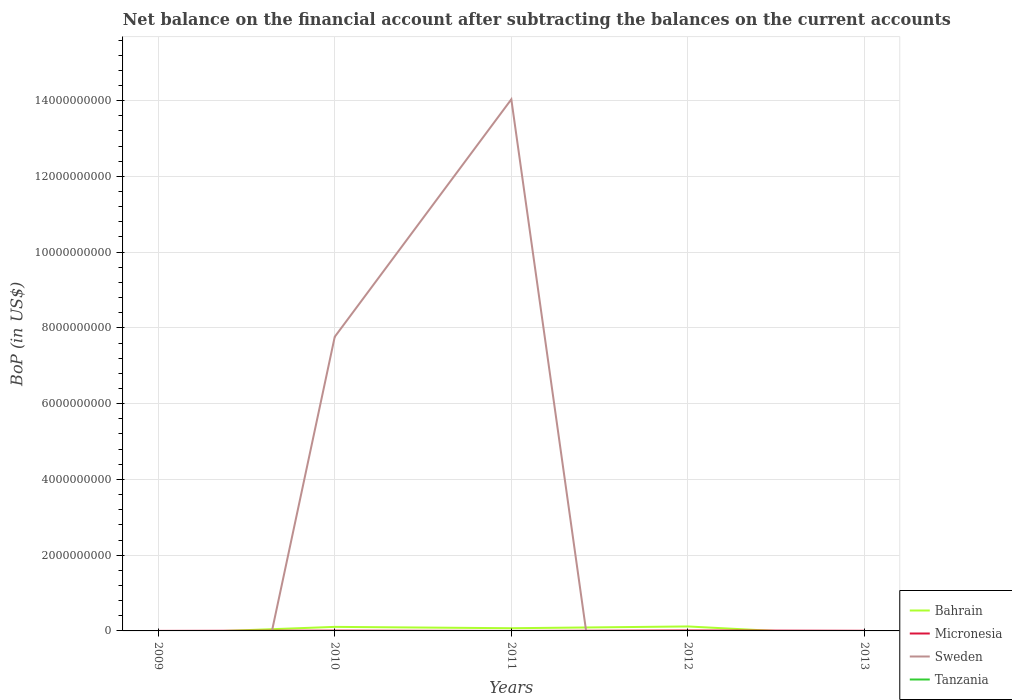How many different coloured lines are there?
Provide a short and direct response. 3. Is the number of lines equal to the number of legend labels?
Keep it short and to the point. No. Across all years, what is the maximum Balance of Payments in Sweden?
Provide a succinct answer. 0. What is the total Balance of Payments in Bahrain in the graph?
Offer a very short reply. 3.54e+07. What is the difference between the highest and the second highest Balance of Payments in Micronesia?
Provide a short and direct response. 1.18e+07. What is the difference between two consecutive major ticks on the Y-axis?
Offer a very short reply. 2.00e+09. Does the graph contain any zero values?
Your answer should be very brief. Yes. Does the graph contain grids?
Your answer should be compact. Yes. How are the legend labels stacked?
Your answer should be compact. Vertical. What is the title of the graph?
Make the answer very short. Net balance on the financial account after subtracting the balances on the current accounts. What is the label or title of the Y-axis?
Provide a succinct answer. BoP (in US$). What is the BoP (in US$) of Micronesia in 2009?
Keep it short and to the point. 9.18e+05. What is the BoP (in US$) of Sweden in 2009?
Keep it short and to the point. 0. What is the BoP (in US$) of Tanzania in 2009?
Give a very brief answer. 0. What is the BoP (in US$) in Bahrain in 2010?
Your answer should be compact. 1.07e+08. What is the BoP (in US$) of Micronesia in 2010?
Provide a short and direct response. 8.05e+06. What is the BoP (in US$) of Sweden in 2010?
Offer a very short reply. 7.76e+09. What is the BoP (in US$) in Tanzania in 2010?
Ensure brevity in your answer.  0. What is the BoP (in US$) in Bahrain in 2011?
Ensure brevity in your answer.  7.15e+07. What is the BoP (in US$) of Sweden in 2011?
Keep it short and to the point. 1.40e+1. What is the BoP (in US$) of Bahrain in 2012?
Your response must be concise. 1.18e+08. What is the BoP (in US$) of Micronesia in 2012?
Offer a terse response. 1.18e+07. What is the BoP (in US$) in Micronesia in 2013?
Ensure brevity in your answer.  3.55e+06. What is the BoP (in US$) of Sweden in 2013?
Make the answer very short. 0. Across all years, what is the maximum BoP (in US$) in Bahrain?
Give a very brief answer. 1.18e+08. Across all years, what is the maximum BoP (in US$) of Micronesia?
Give a very brief answer. 1.18e+07. Across all years, what is the maximum BoP (in US$) of Sweden?
Make the answer very short. 1.40e+1. Across all years, what is the minimum BoP (in US$) in Bahrain?
Provide a succinct answer. 0. Across all years, what is the minimum BoP (in US$) in Micronesia?
Your answer should be very brief. 0. Across all years, what is the minimum BoP (in US$) of Sweden?
Your answer should be very brief. 0. What is the total BoP (in US$) of Bahrain in the graph?
Provide a succinct answer. 2.97e+08. What is the total BoP (in US$) in Micronesia in the graph?
Make the answer very short. 2.43e+07. What is the total BoP (in US$) in Sweden in the graph?
Your response must be concise. 2.18e+1. What is the difference between the BoP (in US$) of Micronesia in 2009 and that in 2010?
Offer a very short reply. -7.13e+06. What is the difference between the BoP (in US$) in Micronesia in 2009 and that in 2012?
Your response must be concise. -1.09e+07. What is the difference between the BoP (in US$) in Micronesia in 2009 and that in 2013?
Your response must be concise. -2.63e+06. What is the difference between the BoP (in US$) in Bahrain in 2010 and that in 2011?
Provide a succinct answer. 3.54e+07. What is the difference between the BoP (in US$) of Sweden in 2010 and that in 2011?
Your response must be concise. -6.27e+09. What is the difference between the BoP (in US$) of Bahrain in 2010 and that in 2012?
Your answer should be compact. -1.11e+07. What is the difference between the BoP (in US$) in Micronesia in 2010 and that in 2012?
Provide a short and direct response. -3.73e+06. What is the difference between the BoP (in US$) in Micronesia in 2010 and that in 2013?
Keep it short and to the point. 4.50e+06. What is the difference between the BoP (in US$) of Bahrain in 2011 and that in 2012?
Provide a succinct answer. -4.65e+07. What is the difference between the BoP (in US$) of Micronesia in 2012 and that in 2013?
Your response must be concise. 8.23e+06. What is the difference between the BoP (in US$) in Micronesia in 2009 and the BoP (in US$) in Sweden in 2010?
Give a very brief answer. -7.76e+09. What is the difference between the BoP (in US$) of Micronesia in 2009 and the BoP (in US$) of Sweden in 2011?
Provide a succinct answer. -1.40e+1. What is the difference between the BoP (in US$) of Bahrain in 2010 and the BoP (in US$) of Sweden in 2011?
Your response must be concise. -1.39e+1. What is the difference between the BoP (in US$) of Micronesia in 2010 and the BoP (in US$) of Sweden in 2011?
Ensure brevity in your answer.  -1.40e+1. What is the difference between the BoP (in US$) in Bahrain in 2010 and the BoP (in US$) in Micronesia in 2012?
Offer a terse response. 9.52e+07. What is the difference between the BoP (in US$) in Bahrain in 2010 and the BoP (in US$) in Micronesia in 2013?
Provide a succinct answer. 1.03e+08. What is the difference between the BoP (in US$) of Bahrain in 2011 and the BoP (in US$) of Micronesia in 2012?
Provide a short and direct response. 5.98e+07. What is the difference between the BoP (in US$) of Bahrain in 2011 and the BoP (in US$) of Micronesia in 2013?
Ensure brevity in your answer.  6.80e+07. What is the difference between the BoP (in US$) of Bahrain in 2012 and the BoP (in US$) of Micronesia in 2013?
Give a very brief answer. 1.15e+08. What is the average BoP (in US$) in Bahrain per year?
Ensure brevity in your answer.  5.93e+07. What is the average BoP (in US$) of Micronesia per year?
Your answer should be very brief. 4.86e+06. What is the average BoP (in US$) in Sweden per year?
Make the answer very short. 4.36e+09. What is the average BoP (in US$) in Tanzania per year?
Keep it short and to the point. 0. In the year 2010, what is the difference between the BoP (in US$) in Bahrain and BoP (in US$) in Micronesia?
Give a very brief answer. 9.89e+07. In the year 2010, what is the difference between the BoP (in US$) of Bahrain and BoP (in US$) of Sweden?
Offer a very short reply. -7.66e+09. In the year 2010, what is the difference between the BoP (in US$) of Micronesia and BoP (in US$) of Sweden?
Offer a terse response. -7.76e+09. In the year 2011, what is the difference between the BoP (in US$) of Bahrain and BoP (in US$) of Sweden?
Offer a terse response. -1.40e+1. In the year 2012, what is the difference between the BoP (in US$) in Bahrain and BoP (in US$) in Micronesia?
Provide a short and direct response. 1.06e+08. What is the ratio of the BoP (in US$) of Micronesia in 2009 to that in 2010?
Your answer should be compact. 0.11. What is the ratio of the BoP (in US$) in Micronesia in 2009 to that in 2012?
Make the answer very short. 0.08. What is the ratio of the BoP (in US$) of Micronesia in 2009 to that in 2013?
Provide a short and direct response. 0.26. What is the ratio of the BoP (in US$) of Bahrain in 2010 to that in 2011?
Your answer should be compact. 1.5. What is the ratio of the BoP (in US$) of Sweden in 2010 to that in 2011?
Your answer should be very brief. 0.55. What is the ratio of the BoP (in US$) of Bahrain in 2010 to that in 2012?
Keep it short and to the point. 0.91. What is the ratio of the BoP (in US$) of Micronesia in 2010 to that in 2012?
Give a very brief answer. 0.68. What is the ratio of the BoP (in US$) of Micronesia in 2010 to that in 2013?
Provide a short and direct response. 2.27. What is the ratio of the BoP (in US$) in Bahrain in 2011 to that in 2012?
Your response must be concise. 0.61. What is the ratio of the BoP (in US$) in Micronesia in 2012 to that in 2013?
Offer a terse response. 3.32. What is the difference between the highest and the second highest BoP (in US$) in Bahrain?
Give a very brief answer. 1.11e+07. What is the difference between the highest and the second highest BoP (in US$) of Micronesia?
Your response must be concise. 3.73e+06. What is the difference between the highest and the lowest BoP (in US$) of Bahrain?
Offer a terse response. 1.18e+08. What is the difference between the highest and the lowest BoP (in US$) in Micronesia?
Your answer should be very brief. 1.18e+07. What is the difference between the highest and the lowest BoP (in US$) in Sweden?
Your answer should be very brief. 1.40e+1. 